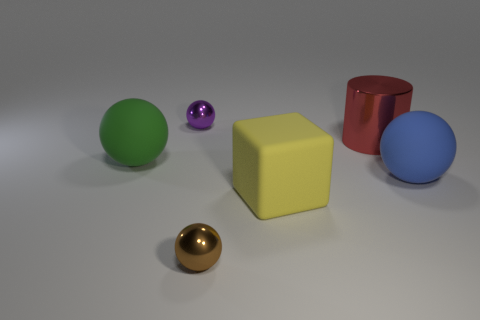Can you estimate the relative distances between these objects? While the exact distances cannot be precisely determined from this angle, the green sphere looks to be the furthest object on the left. The gold and purple spheres are closer to the viewer, positioned in the foreground. The blue sphere is slightly behind the yellow cube, and the red cylinder is to the right side at what seems to be the same plane as the yellow cube. 